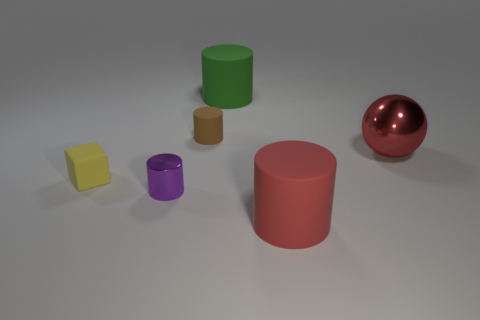There is a brown object; what number of green matte things are left of it?
Your answer should be very brief. 0. Are there fewer big red spheres than shiny things?
Provide a short and direct response. Yes. There is a thing that is both to the left of the big metal thing and to the right of the green rubber cylinder; how big is it?
Keep it short and to the point. Large. Is the color of the matte thing that is in front of the tiny yellow block the same as the small matte cylinder?
Provide a short and direct response. No. Is the number of green rubber cylinders that are right of the big red shiny thing less than the number of rubber cylinders?
Ensure brevity in your answer.  Yes. The red thing that is made of the same material as the purple object is what shape?
Your answer should be compact. Sphere. Is the material of the large green cylinder the same as the block?
Offer a terse response. Yes. Is the number of blocks that are in front of the small purple object less than the number of large green matte cylinders in front of the green cylinder?
Provide a short and direct response. No. There is a cylinder that is the same color as the ball; what size is it?
Provide a succinct answer. Large. What number of small brown matte cylinders are to the left of the large matte cylinder that is in front of the shiny object to the left of the big green matte object?
Your answer should be very brief. 1. 